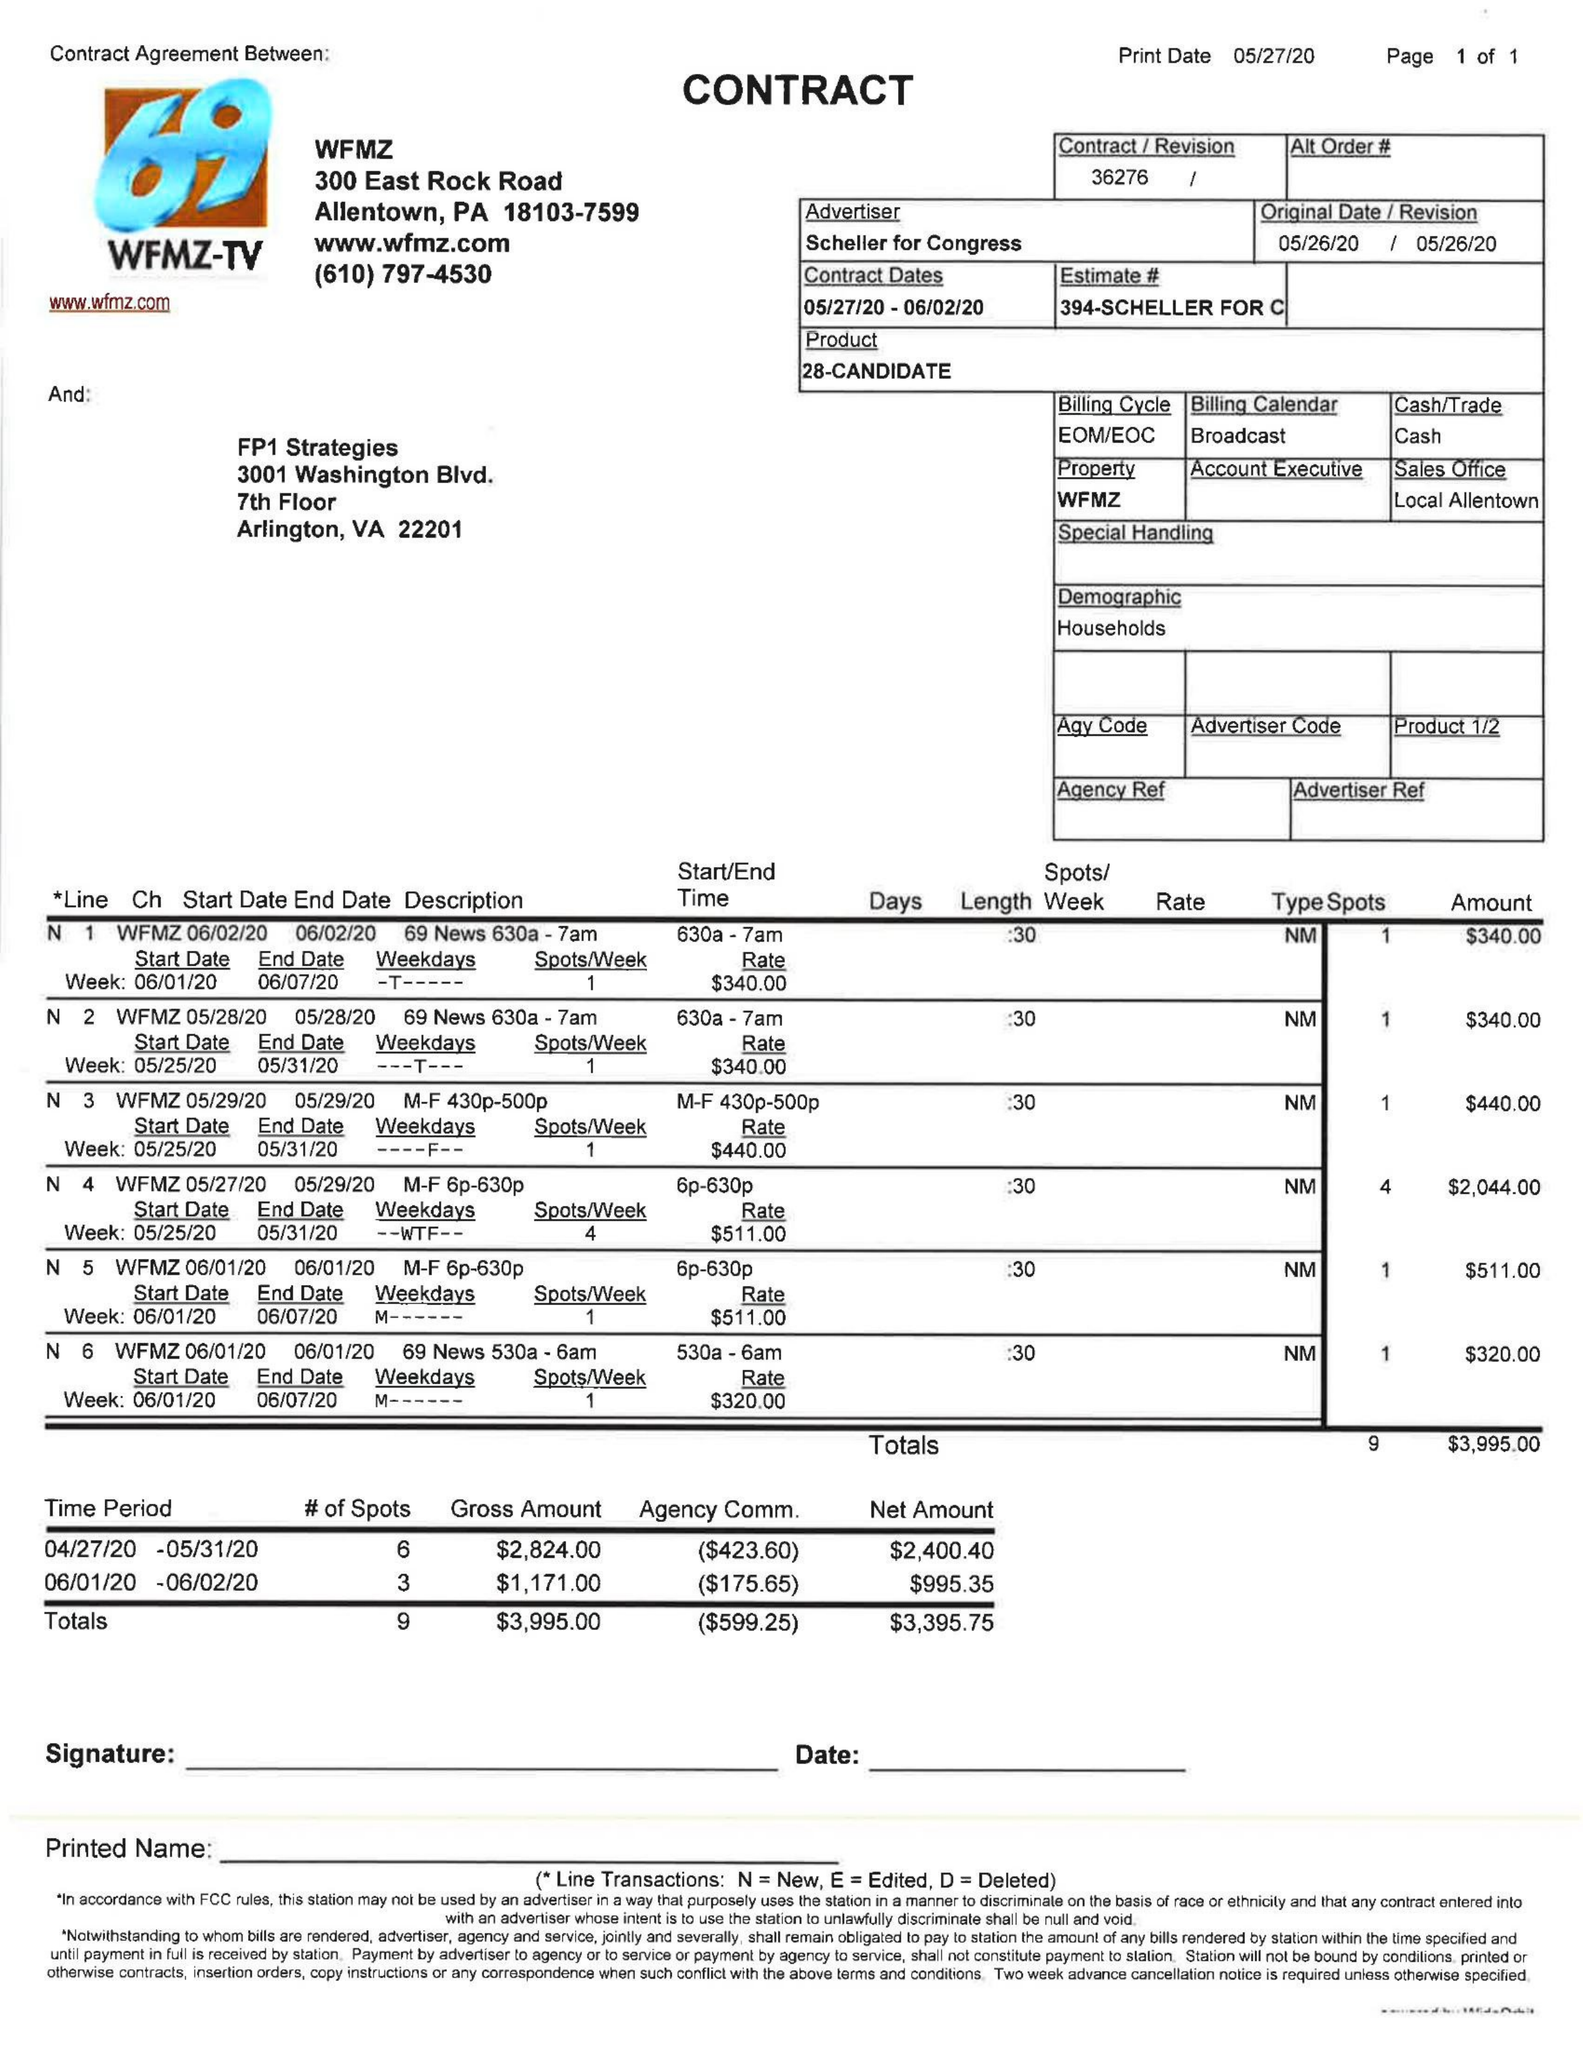What is the value for the contract_num?
Answer the question using a single word or phrase. 36276 